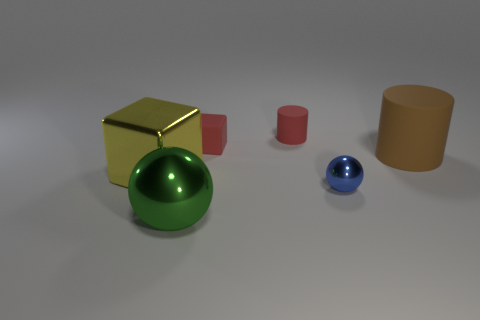Add 1 small metal objects. How many objects exist? 7 Subtract all spheres. How many objects are left? 4 Add 3 large green metal spheres. How many large green metal spheres exist? 4 Subtract 0 cyan blocks. How many objects are left? 6 Subtract all large red shiny spheres. Subtract all metallic objects. How many objects are left? 3 Add 6 big objects. How many big objects are left? 9 